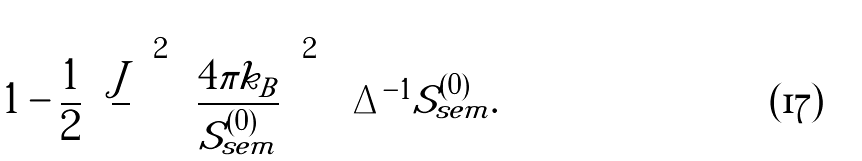Convert formula to latex. <formula><loc_0><loc_0><loc_500><loc_500>\left [ 1 - \frac { 1 } { 2 } \left ( \frac { J } { } \right ) ^ { 2 } \left ( \frac { 4 \pi k _ { B } } { S _ { s e m } ^ { ( 0 ) } } \right ) ^ { 2 } \right ] { \Delta } ^ { - 1 } S _ { s e m } ^ { ( 0 ) } .</formula> 